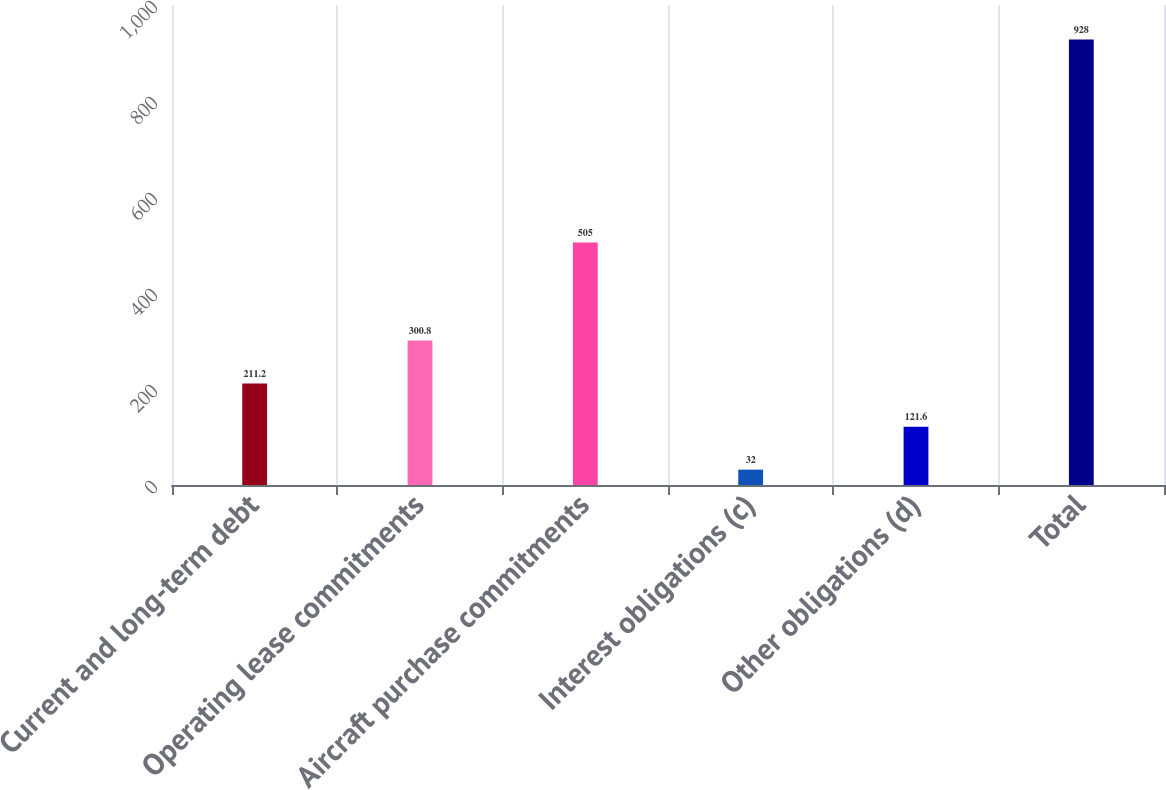Convert chart to OTSL. <chart><loc_0><loc_0><loc_500><loc_500><bar_chart><fcel>Current and long-term debt<fcel>Operating lease commitments<fcel>Aircraft purchase commitments<fcel>Interest obligations (c)<fcel>Other obligations (d)<fcel>Total<nl><fcel>211.2<fcel>300.8<fcel>505<fcel>32<fcel>121.6<fcel>928<nl></chart> 